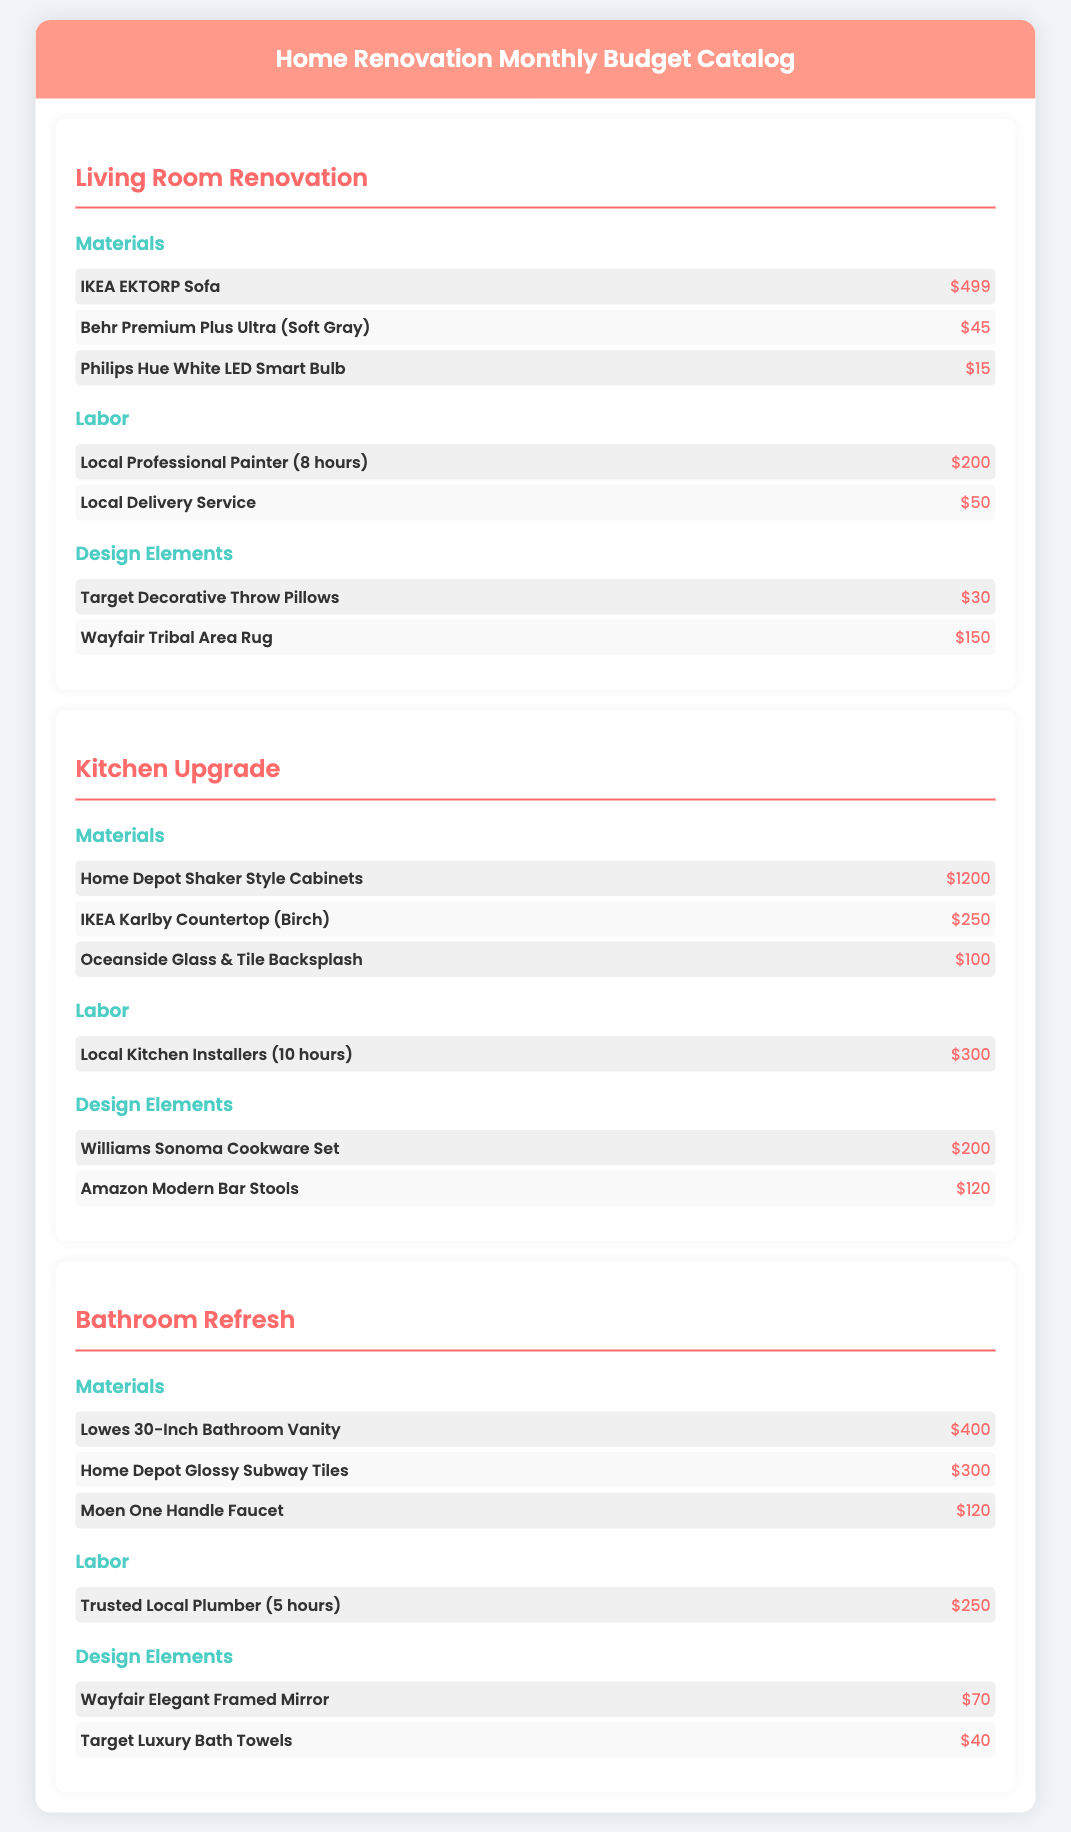What is the cost of the IKEA EKTORP Sofa? The document lists the cost of the IKEA EKTORP Sofa under Living Room Renovation, which is $499.
Answer: $499 How much does the Home Depot Shaker Style Cabinets cost? The cost of the Home Depot Shaker Style Cabinets is specified in the Kitchen Upgrade section as $1200.
Answer: $1200 What is the labor cost for the Local Professional Painter? The document states the labor cost for the Local Professional Painter (8 hours) is $200.
Answer: $200 What decorative item is listed under Design Elements for the Living Room? The Target Decorative Throw Pillows are mentioned as a decorative item under Design Elements for the Living Room.
Answer: Target Decorative Throw Pillows How much do the Moen One Handle Faucet and Home Depot Glossy Subway Tiles cost together? The Moen One Handle Faucet costs $120 and the Home Depot Glossy Subway Tiles cost $300; their total is $120 + $300 = $420.
Answer: $420 Which costs less, the Wayfair Elegant Framed Mirror or the Target Luxury Bath Towels? The document indicates that the Wayfair Elegant Framed Mirror costs $70 and the Target Luxury Bath Towels cost $40; hence, the Target Luxury Bath Towels cost less.
Answer: Target Luxury Bath Towels What is the total estimated cost for Labor in the Kitchen Upgrade? The document shows that the only labor cost listed under Kitchen Upgrade is $300 for Local Kitchen Installers.
Answer: $300 How many items are listed in the Bathroom Refresh for Materials? There are three items listed in the Bathroom Refresh under the Materials category.
Answer: 3 items What type of document is this? The document serves as a Monthly Budget Catalog for home renovation detailing estimated costs for various elements.
Answer: Monthly Budget Catalog 